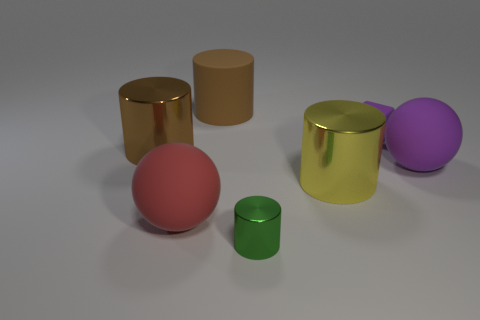What number of purple matte blocks are there?
Provide a succinct answer. 1. There is a large yellow metallic object; is it the same shape as the small object that is in front of the large purple matte object?
Ensure brevity in your answer.  Yes. There is a rubber sphere left of the small green shiny thing; how big is it?
Ensure brevity in your answer.  Large. What is the material of the large red object?
Make the answer very short. Rubber. There is a purple matte thing that is right of the small purple cube; is it the same shape as the tiny green metallic object?
Provide a succinct answer. No. There is a sphere that is the same color as the tiny matte block; what is its size?
Offer a very short reply. Large. Is there a metal cylinder of the same size as the brown matte object?
Keep it short and to the point. Yes. Are there any large brown matte cylinders behind the brown object that is on the right side of the ball to the left of the tiny metallic cylinder?
Provide a succinct answer. No. Is the color of the matte block the same as the rubber sphere that is right of the large red ball?
Your response must be concise. Yes. There is a cylinder to the left of the large sphere that is to the left of the purple thing that is right of the purple cube; what is it made of?
Provide a succinct answer. Metal. 